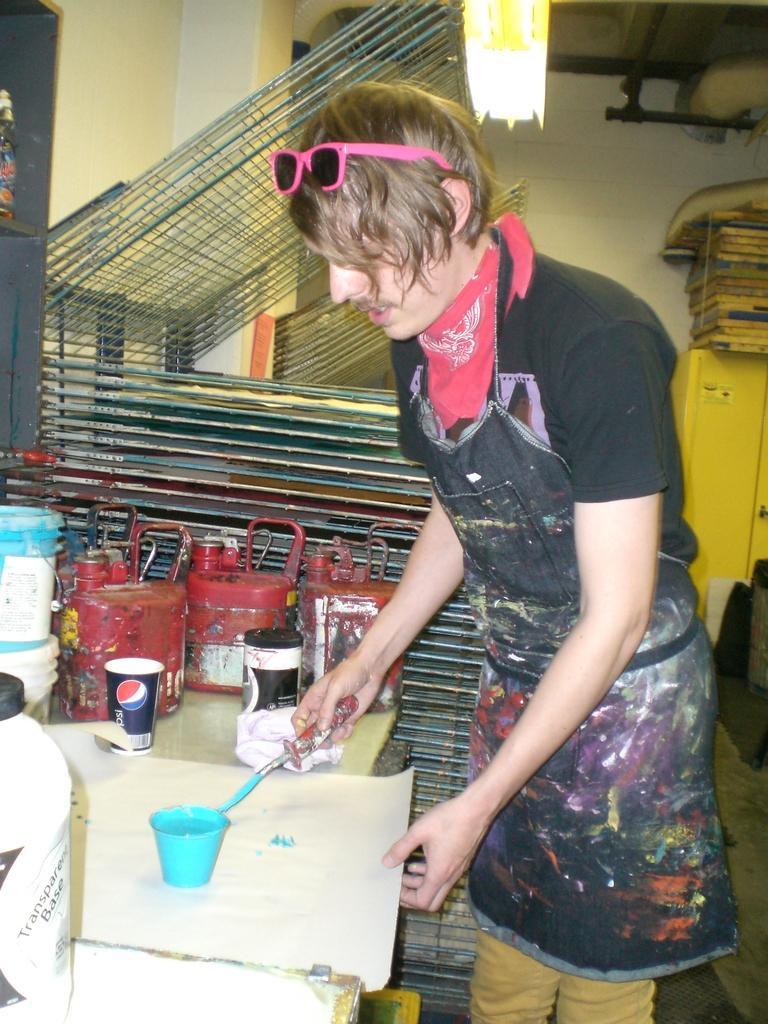Please provide a concise description of this image. In this picture we can see a man is holding a paper and a stick in his hands, in front of him we can see cups and couple of cans on the table. 